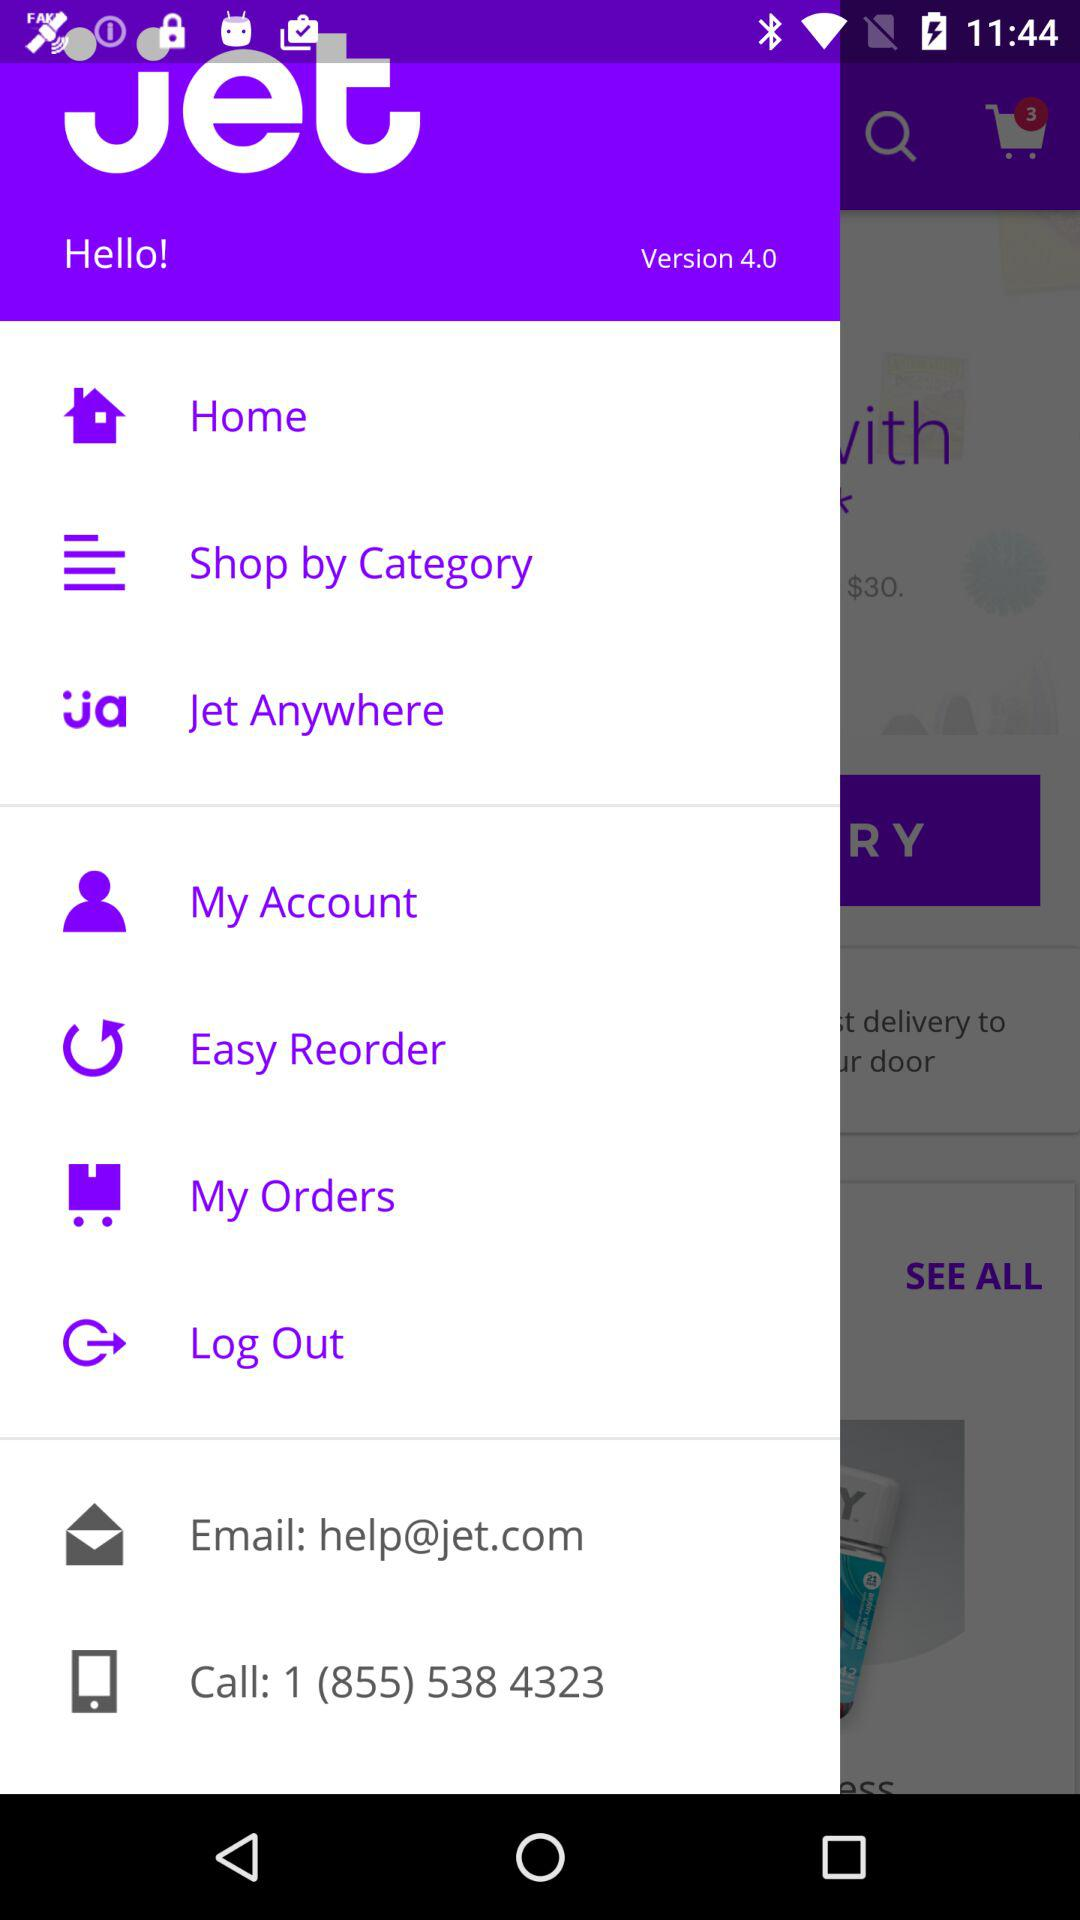What's the contact number? The contact number is 1 (855) 538 4323. 